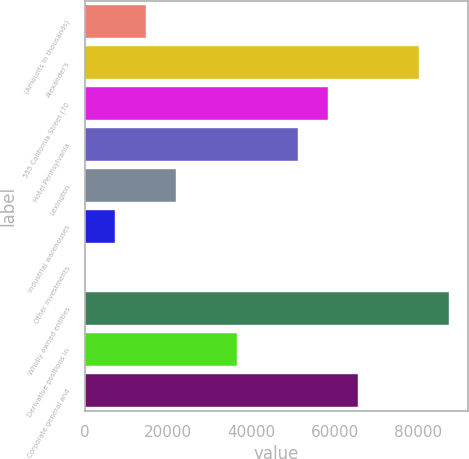Convert chart. <chart><loc_0><loc_0><loc_500><loc_500><bar_chart><fcel>(Amounts in thousands)<fcel>Alexander's<fcel>555 California Street (70<fcel>Hotel Pennsylvania<fcel>Lexington<fcel>Industrial warehouses<fcel>Other investments<fcel>Wholly owned entities<fcel>Derivative positions in<fcel>Corporate general and<nl><fcel>14656.6<fcel>80116.3<fcel>58296.4<fcel>51023.1<fcel>21929.9<fcel>7383.3<fcel>110<fcel>87389.6<fcel>36476.5<fcel>65569.7<nl></chart> 